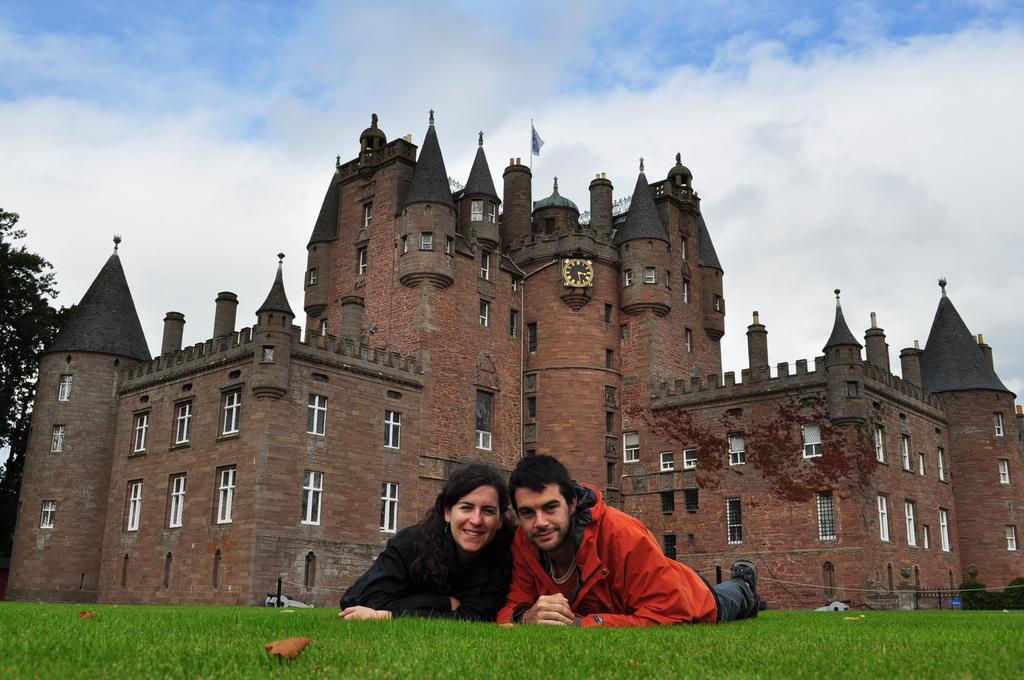In one or two sentences, can you explain what this image depicts? In this image in the front there is grass on the ground and in the center there are persons lying and smiling. In the background there is a castle and on the wall of the castle, there is a clock and on the top of the castle there is a flag. On the left side there are trees and the sky is cloudy and on the right side there are plants. 